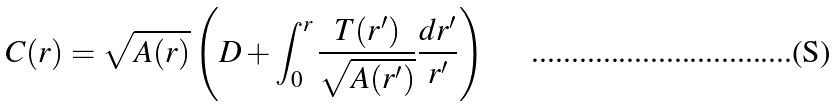Convert formula to latex. <formula><loc_0><loc_0><loc_500><loc_500>C ( r ) = \sqrt { A ( r ) } \left ( D + \int _ { 0 } ^ { r } \frac { T ( r ^ { \prime } ) } { \sqrt { A ( r ^ { \prime } ) } } \frac { d r ^ { \prime } } { r ^ { \prime } } \right )</formula> 